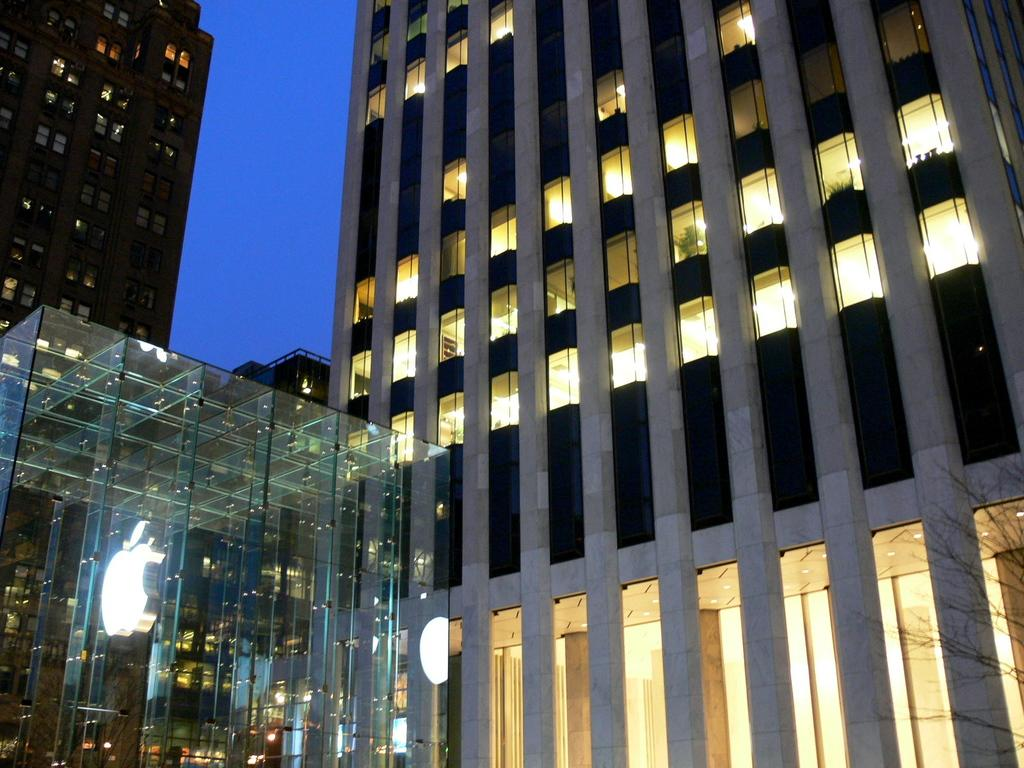What type of structures are present in the image? There are buildings in the image. Can you describe the lighting inside the buildings? There is light visible inside the buildings. What is visible at the top of the image? The sky is visible at the top of the image. What is located in the foreground of the image? There is a logo in the foreground of the image. How many beggars can be seen holding buckets in the image? There are no beggars or buckets present in the image. What type of balls are being used in the game depicted in the image? There is no game or balls depicted in the image. 